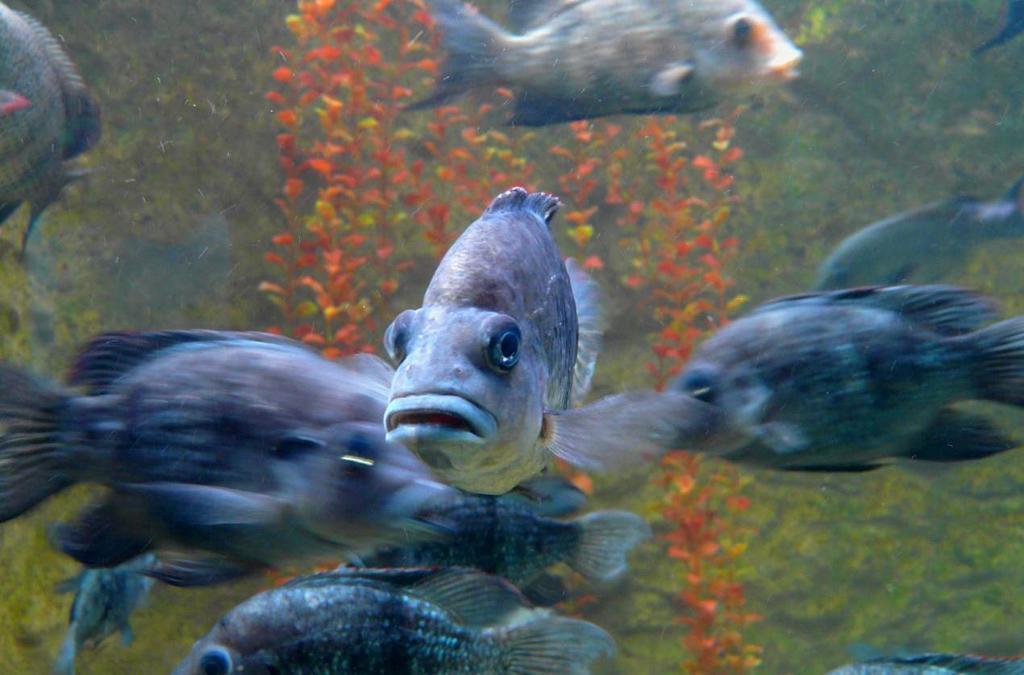Could you give a brief overview of what you see in this image? In this image I can see a shoal of fish in the water and submarine plants. This image is taken may be in the sea. 